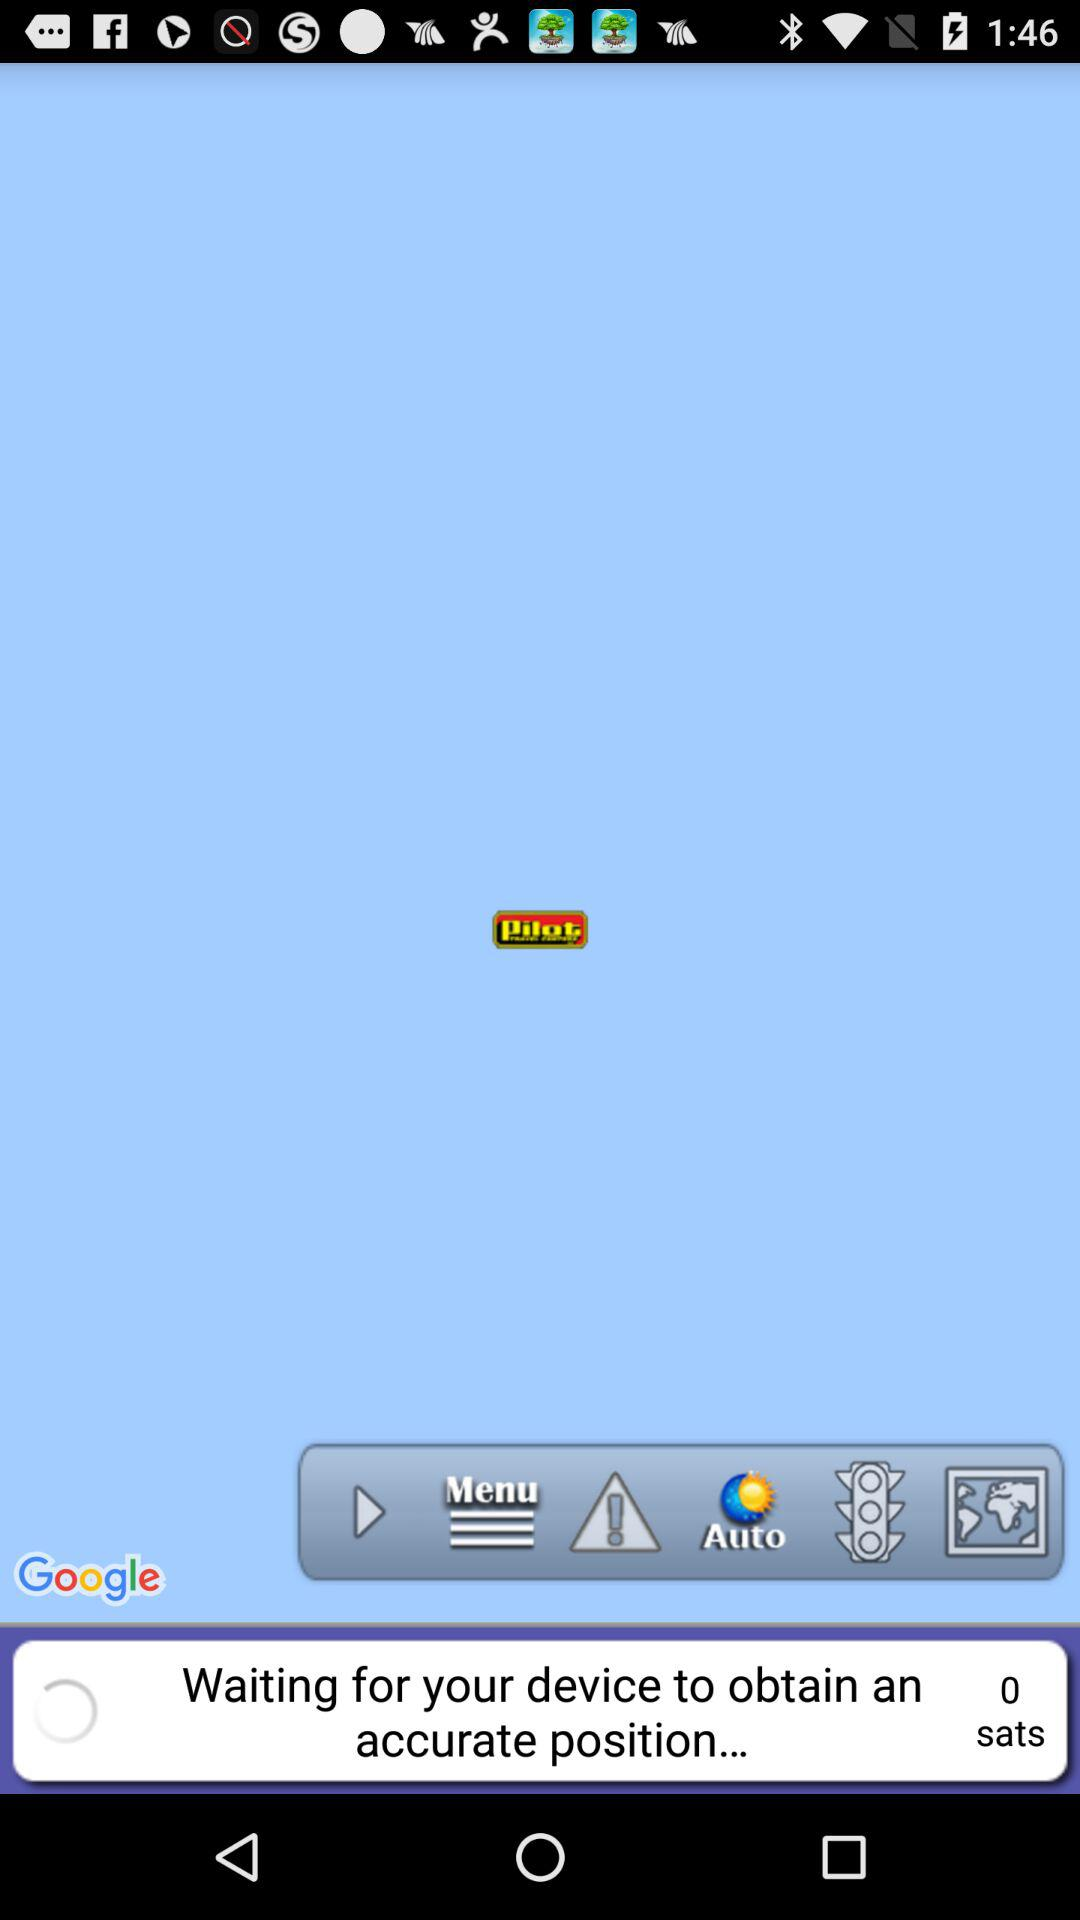How many sats are there?
Answer the question using a single word or phrase. 0 